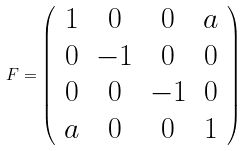Convert formula to latex. <formula><loc_0><loc_0><loc_500><loc_500>F = \left ( \begin{array} { c c c c } 1 & 0 & 0 & a \\ 0 & - 1 & 0 & 0 \\ 0 & 0 & - 1 & 0 \\ a & 0 & 0 & 1 \end{array} \right )</formula> 